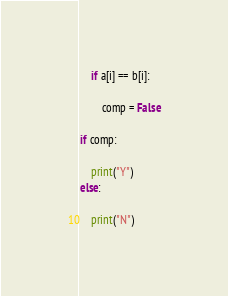<code> <loc_0><loc_0><loc_500><loc_500><_Python_>    if a[i] == b[i]:

        comp = False

if comp:

    print("Y")
else:

    print("N")</code> 